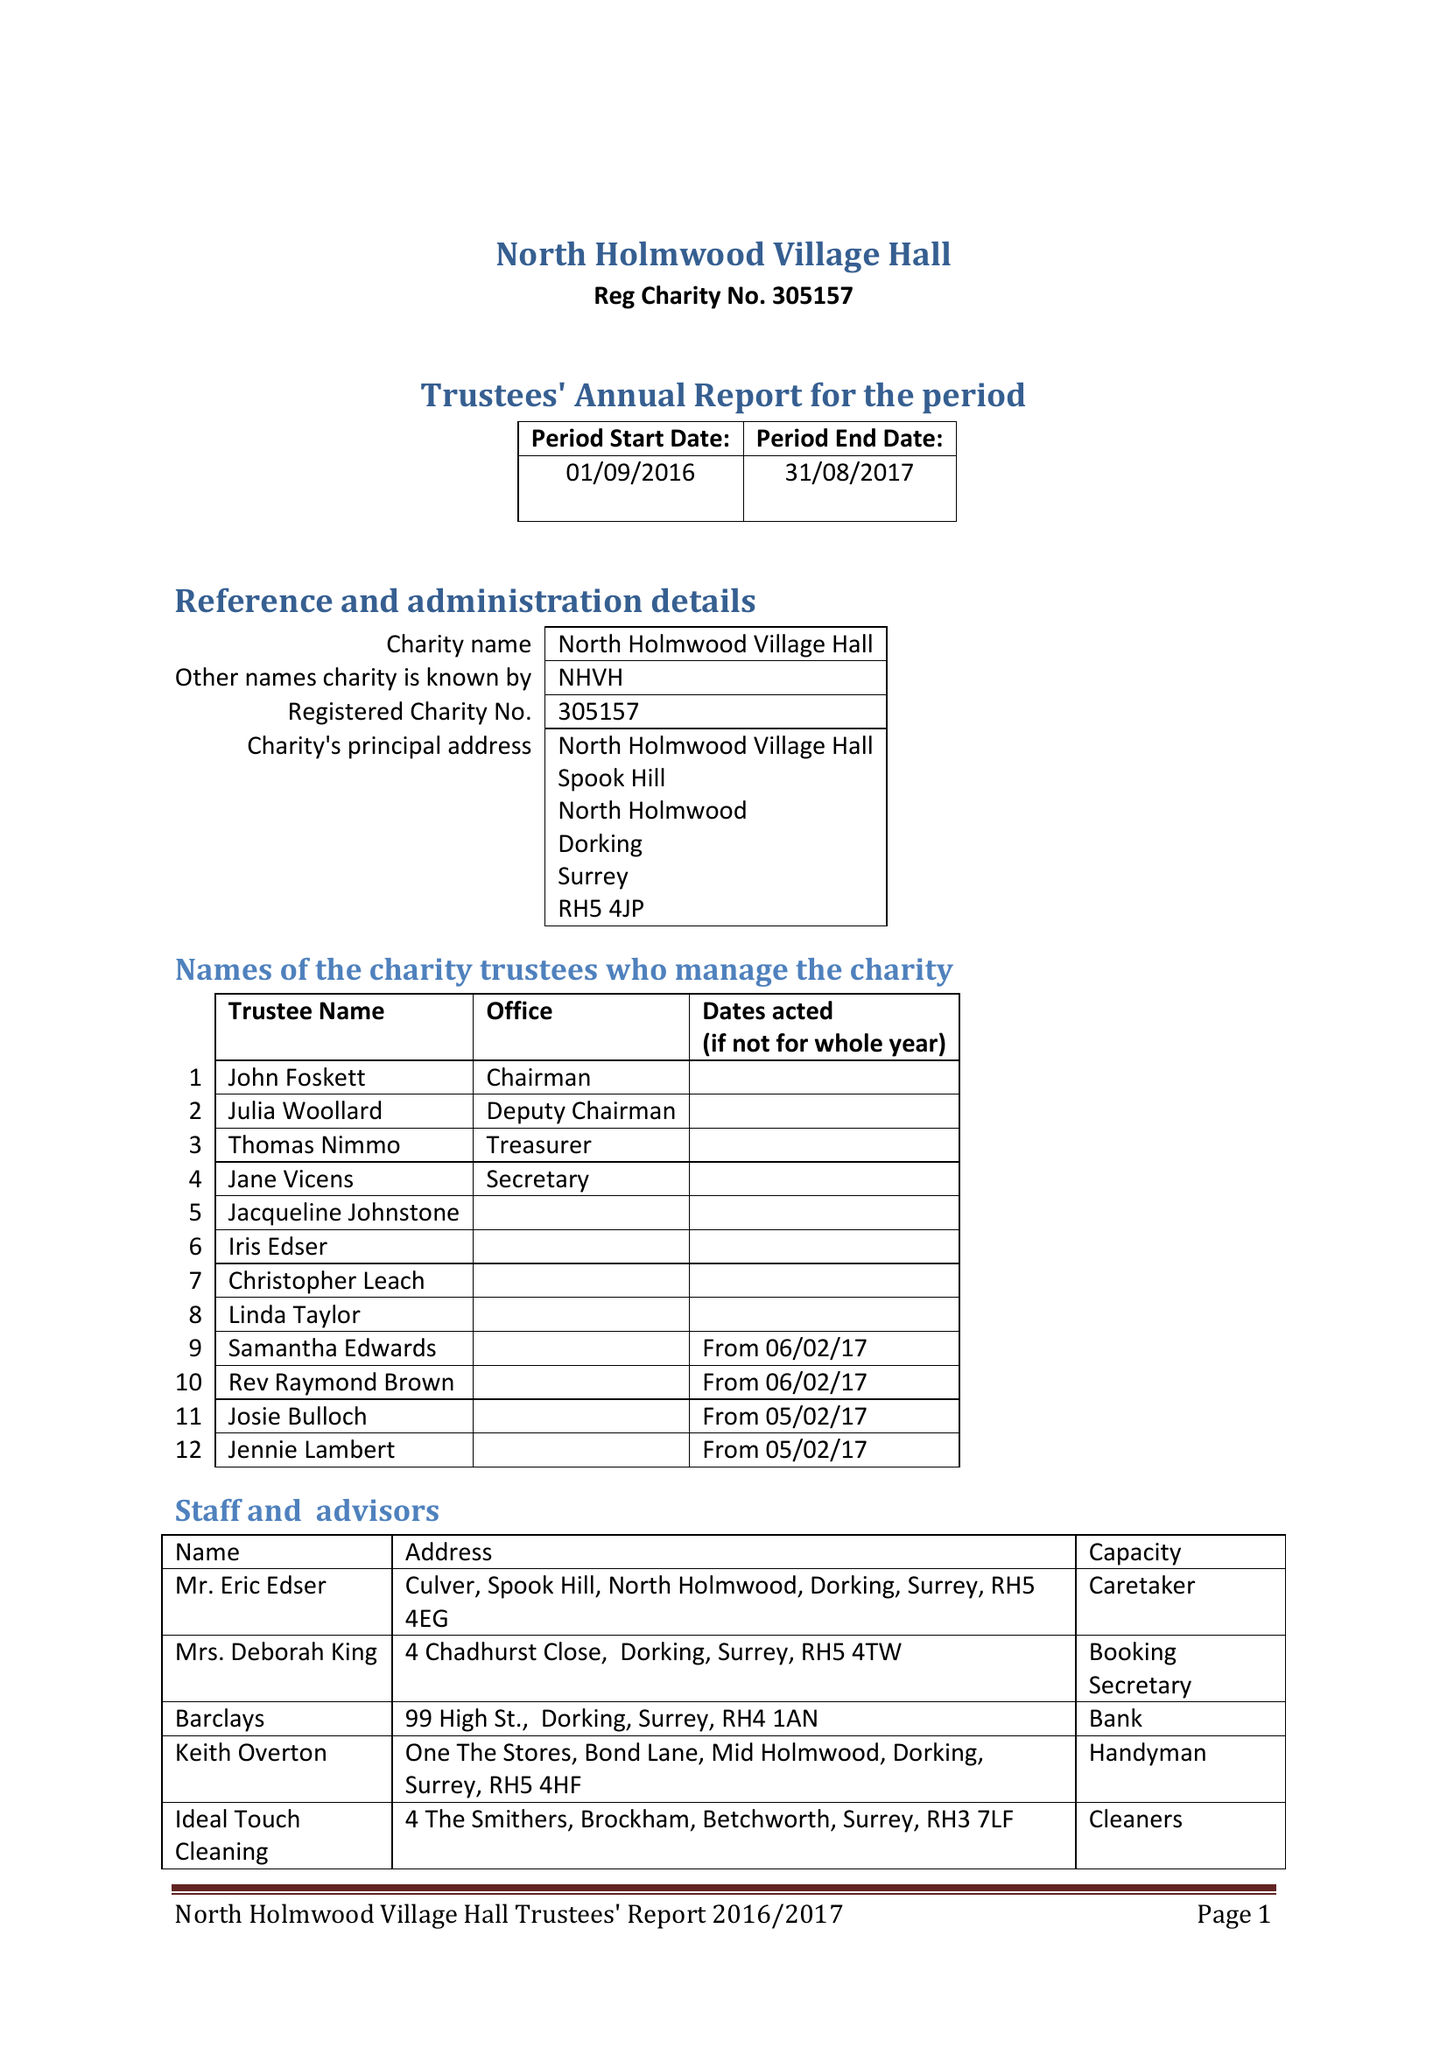What is the value for the address__post_town?
Answer the question using a single word or phrase. DORKING 